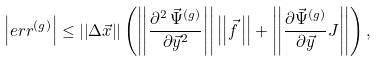Convert formula to latex. <formula><loc_0><loc_0><loc_500><loc_500>\left | e r r ^ { ( g ) } \right | \leq \left | \left | \Delta \vec { x } \right | \right | \left ( \left | \left | \frac { \partial ^ { 2 } \, \vec { \Psi } ^ { ( g ) } } { \partial \vec { y } ^ { 2 } } \right | \right | \left | \left | \vec { f } \, \right | \right | + \left | \left | \frac { \partial \vec { \Psi } ^ { ( g ) } } { \partial \vec { y } } J \right | \right | \right ) ,</formula> 